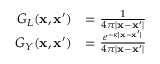Convert formula to latex. <formula><loc_0><loc_0><loc_500><loc_500>\begin{array} { r l } { G _ { L } ( x , x ^ { \prime } ) } & { = \frac { 1 } { 4 \pi | x - x ^ { \prime } | } } \\ { G _ { Y } ( x , x ^ { \prime } ) } & { = \frac { e ^ { - \kappa | x - x ^ { \prime } | } } { 4 \pi | x - x ^ { \prime } | } } \end{array}</formula> 